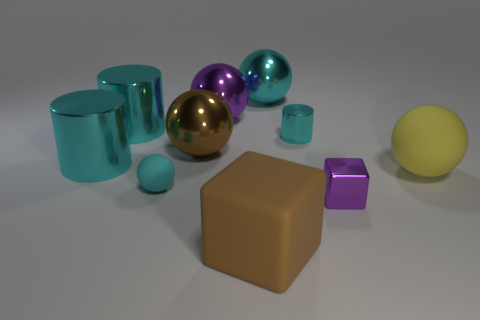How many cyan cylinders must be subtracted to get 1 cyan cylinders? 2 Subtract 2 spheres. How many spheres are left? 3 Subtract all yellow spheres. How many spheres are left? 4 Subtract all purple metal spheres. How many spheres are left? 4 Subtract all blue spheres. Subtract all green cubes. How many spheres are left? 5 Subtract all cylinders. How many objects are left? 7 Add 3 big cubes. How many big cubes are left? 4 Add 5 tiny blue shiny things. How many tiny blue shiny things exist? 5 Subtract 0 yellow cylinders. How many objects are left? 10 Subtract all small purple metallic things. Subtract all small green shiny cubes. How many objects are left? 9 